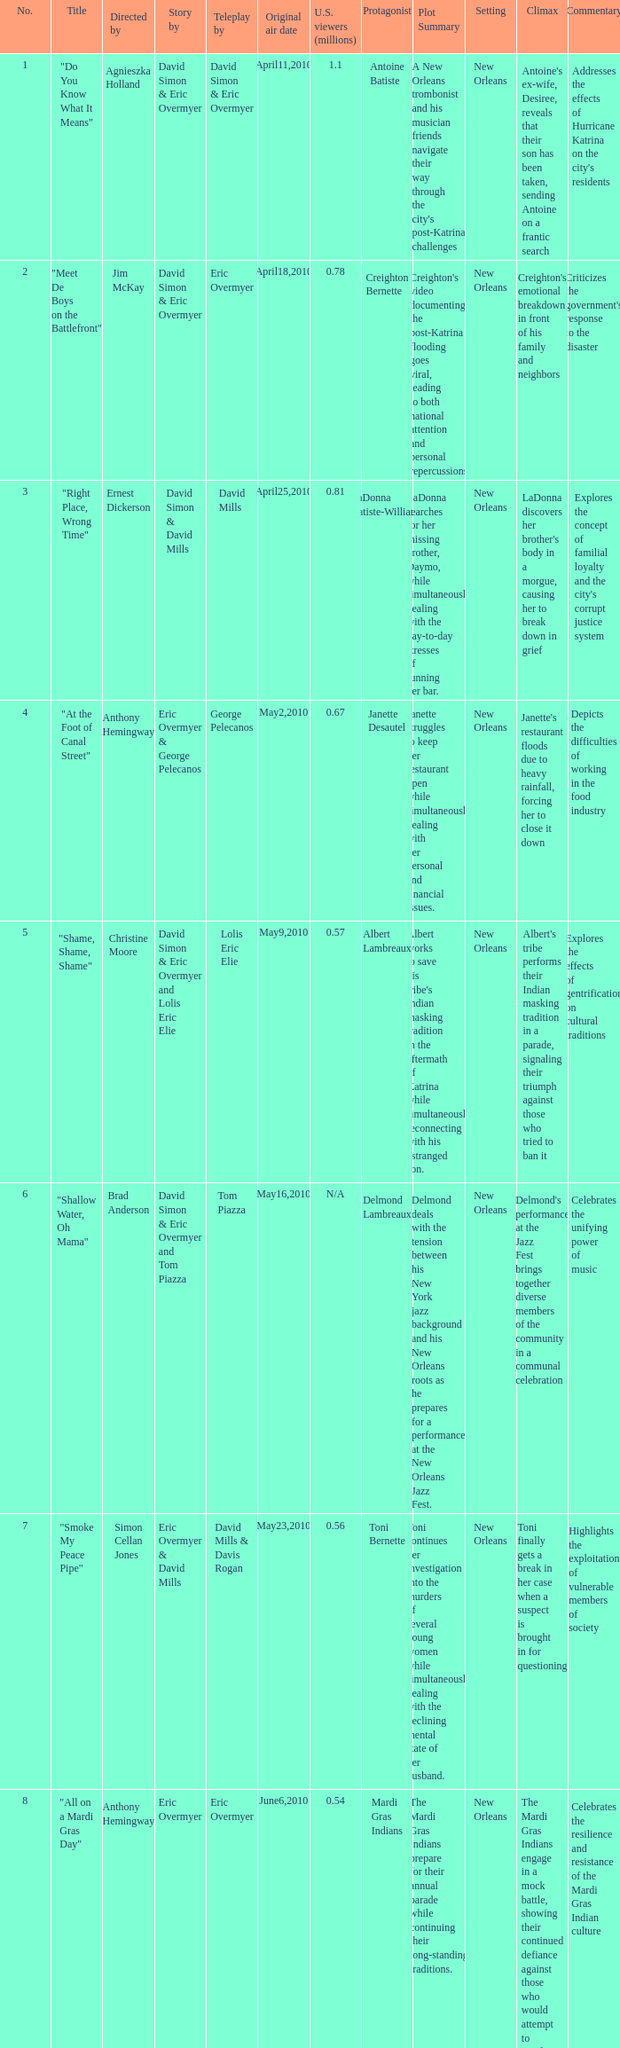Name the teleplay for  david simon & eric overmyer and tom piazza Tom Piazza. 